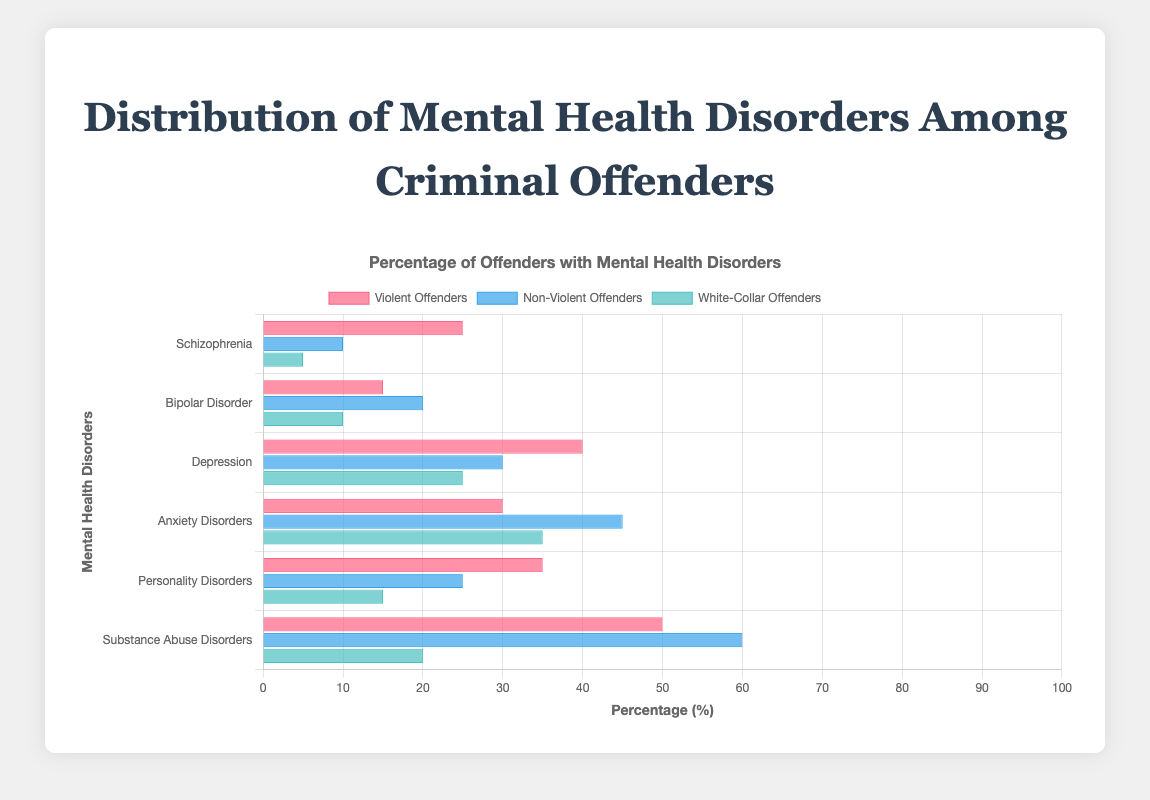Which offender group shows the highest percentage of Substance Abuse Disorders? The bar for Substance Abuse Disorders among Non-Violent Offenders is the tallest.
Answer: Non-Violent Offenders What is the difference in the percentage of Depression between Violent and White-Collar Offenders? The percentage for Depression among Violent Offenders is 40, and among White-Collar Offenders is 25. The difference is 40 - 25 = 15.
Answer: 15 Which mental health disorder is most common among Violent Offenders? The bar representing Substance Abuse Disorders is the longest among the bars for Violent Offenders, indicating it is the most common.
Answer: Substance Abuse Disorders Is Anxiety Disorders more prevalent among Non-Violent Offenders or White-Collar Offenders? The bar for Anxiety Disorders (blue) among Non-Violent Offenders is taller than the bar among White-Collar Offenders (green), indicating a higher prevalence.
Answer: Non-Violent Offenders How does the occurrence of Bipolar Disorder compare between Non-Violent and Violent Offenders? The data shows 20% for Non-Violent Offenders and 15% for Violent Offenders. Bipolar Disorder is more prevalent among Non-Violent Offenders.
Answer: Non-Violent Offenders What is the sum of percentages for Personality Disorders and Substance Abuse Disorders in White-Collar Offenders? The percentages are 15 for Personality Disorders and 20 for Substance Abuse Disorders. The sum is 15 + 20 = 35.
Answer: 35 Which group has the lowest percentage of Schizophrenia? The bar for Schizophrenia among White-Collar Offenders is the shortest.
Answer: White-Collar Offenders Is Schizophrenia more common among Violent Offenders or Non-Violent Offenders? The percentage is 25 for Violent Offenders and 10 for Non-Violent Offenders. It is more common among Violent Offenders.
Answer: Violent Offenders What is the average percentage of Anxiety Disorders across all offender groups? The percentages for Anxiety Disorders are 30 (Violent), 45 (Non-Violent), and 35 (White-Collar). The average is (30 + 45 + 35) / 3 = 110 / 3 = 36.67
Answer: 36.67 Which group has the highest overall percentage sum for all mental health disorders? Summing the percentages: Violent (25+15+40+30+35+50=195), Non-Violent (10+20+30+45+25+60=190), White-Collar (5+10+25+35+15+20=110). Violent Offenders have the highest sum.
Answer: Violent Offenders 